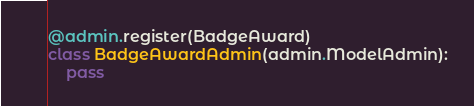<code> <loc_0><loc_0><loc_500><loc_500><_Python_>

@admin.register(BadgeAward)
class BadgeAwardAdmin(admin.ModelAdmin):
    pass
</code> 